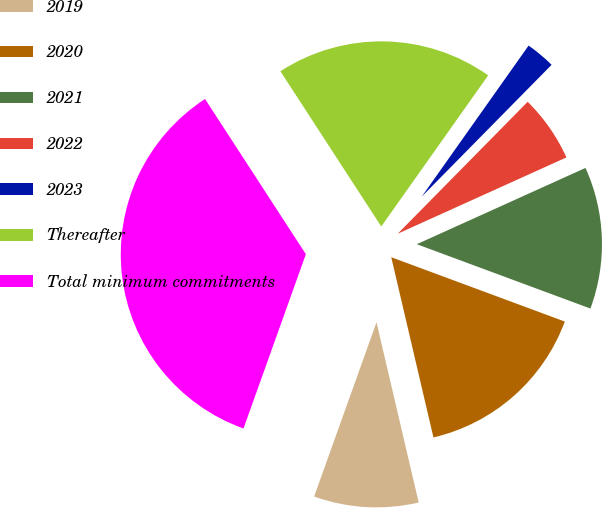Convert chart. <chart><loc_0><loc_0><loc_500><loc_500><pie_chart><fcel>2019<fcel>2020<fcel>2021<fcel>2022<fcel>2023<fcel>Thereafter<fcel>Total minimum commitments<nl><fcel>9.13%<fcel>15.69%<fcel>12.41%<fcel>5.86%<fcel>2.58%<fcel>18.97%<fcel>35.36%<nl></chart> 